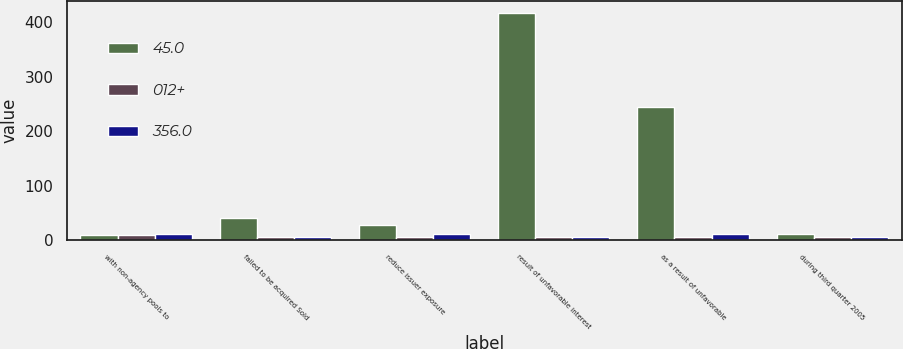Convert chart to OTSL. <chart><loc_0><loc_0><loc_500><loc_500><stacked_bar_chart><ecel><fcel>with non-agency pools to<fcel>failed to be acquired Sold<fcel>reduce issuer exposure<fcel>result of unfavorable interest<fcel>as a result of unfavorable<fcel>during third quarter 2005<nl><fcel>45.0<fcel>9<fcel>40<fcel>27<fcel>418<fcel>244<fcel>12<nl><fcel>012+<fcel>9<fcel>6<fcel>6<fcel>5<fcel>5<fcel>5<nl><fcel>356.0<fcel>12<fcel>6<fcel>12<fcel>6<fcel>12<fcel>6<nl></chart> 